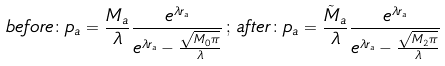Convert formula to latex. <formula><loc_0><loc_0><loc_500><loc_500>b e f o r e \colon p _ { a } = \frac { M _ { a } } { \lambda } \frac { e ^ { \lambda r _ { a } } } { e ^ { \lambda r _ { a } } - \frac { \sqrt { M _ { 0 } \pi } } { \lambda } } \, ; \, a f t e r \colon p _ { a } = \frac { \tilde { M } _ { a } } { \lambda } \frac { e ^ { \lambda r _ { a } } } { e ^ { \lambda r _ { a } } - \frac { \sqrt { M _ { 2 } \pi } } { \lambda } }</formula> 